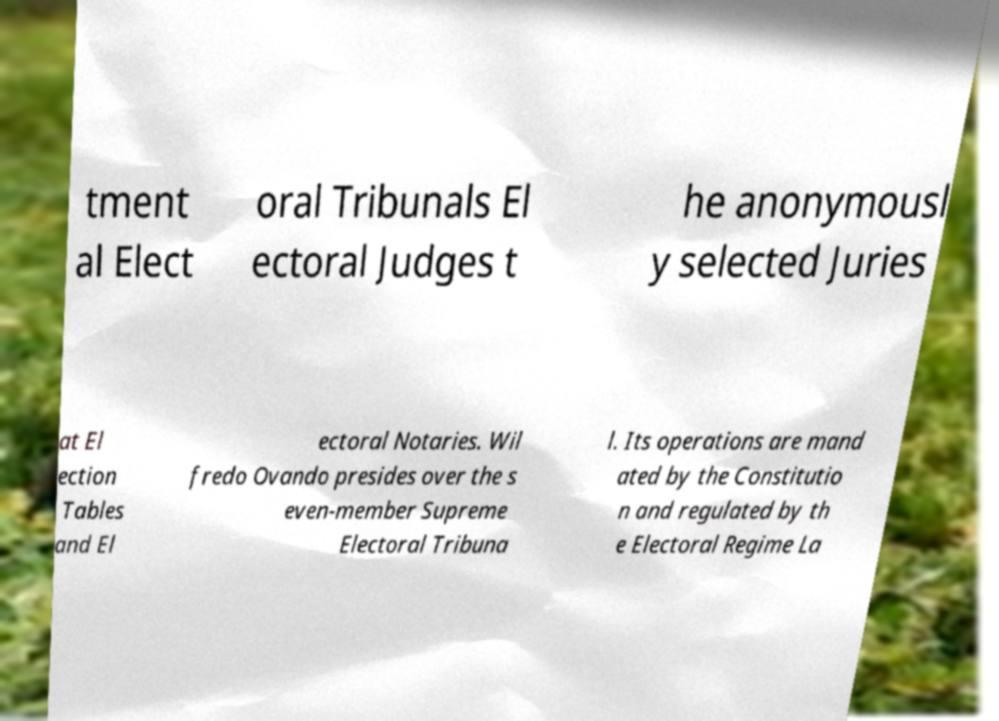Could you extract and type out the text from this image? tment al Elect oral Tribunals El ectoral Judges t he anonymousl y selected Juries at El ection Tables and El ectoral Notaries. Wil fredo Ovando presides over the s even-member Supreme Electoral Tribuna l. Its operations are mand ated by the Constitutio n and regulated by th e Electoral Regime La 